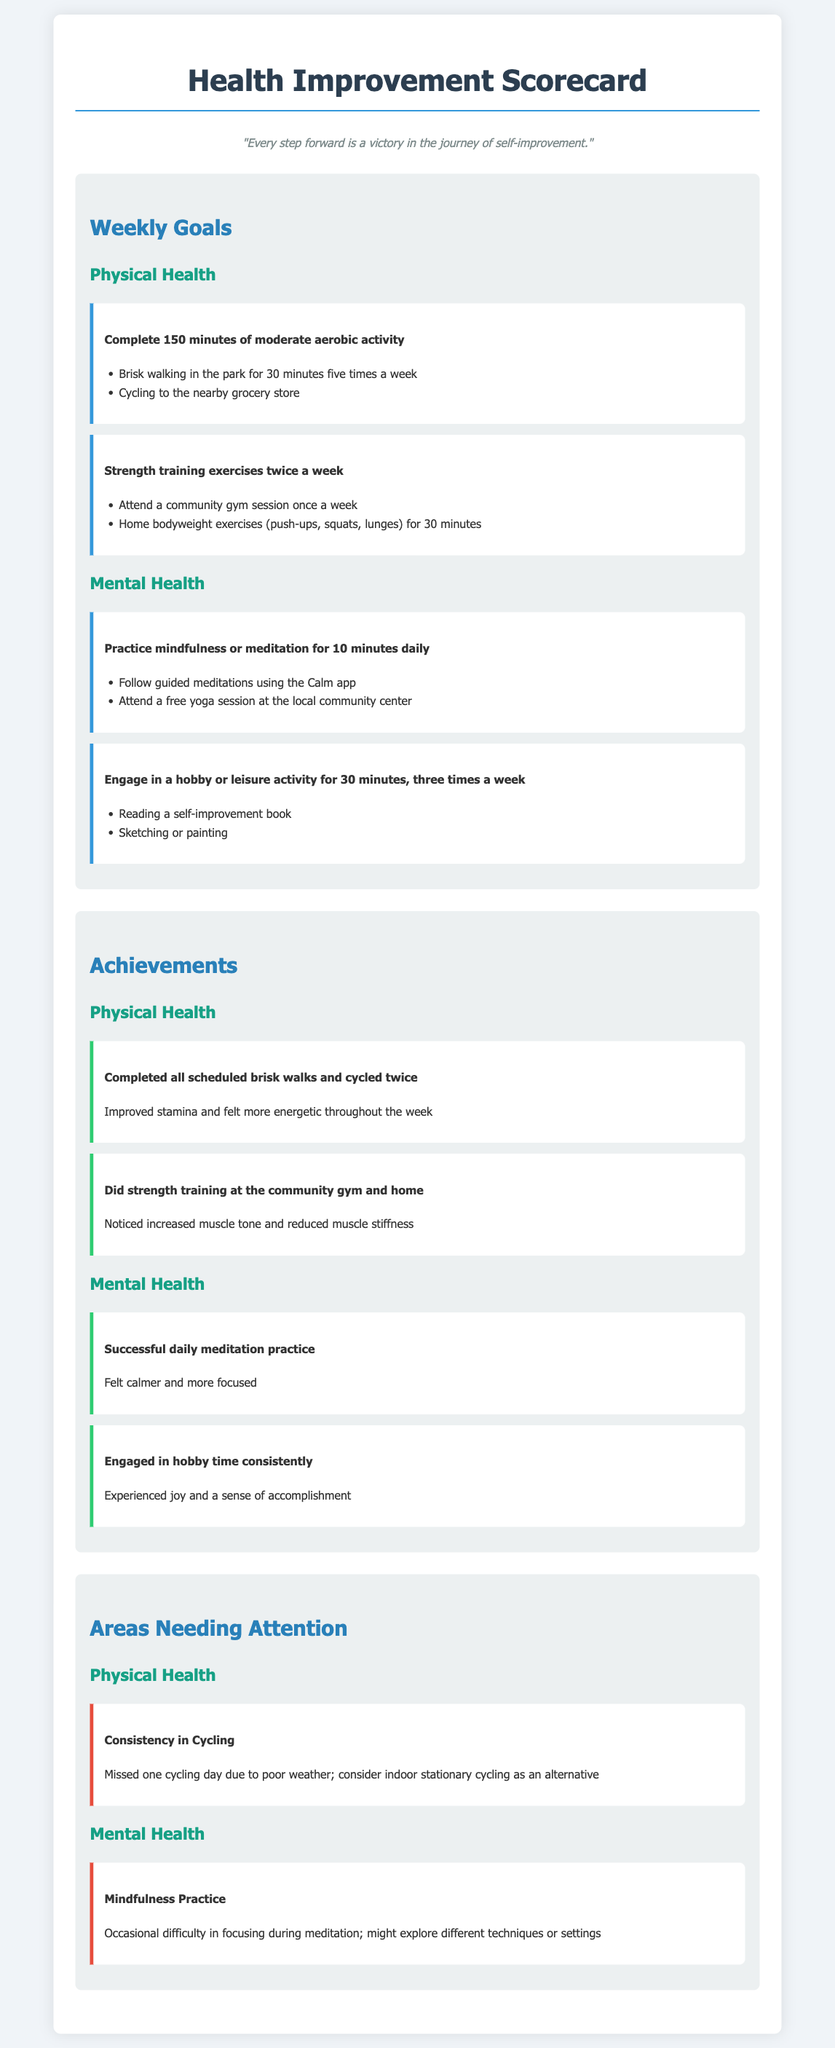What is the total amount of moderate aerobic activity to complete weekly? The total amount of moderate aerobic activity is specified as 150 minutes per week.
Answer: 150 minutes What is one physical health goal? One physical health goal is to complete 150 minutes of moderate aerobic activity.
Answer: Complete 150 minutes of moderate aerobic activity How many days a week should strength training be practiced? The document states strength training should be practiced twice a week.
Answer: Twice a week What was achieved regarding cycling? The achievement noted that the individual cycled twice during the week.
Answer: Cycled twice What area needs attention in mental health? The area needing attention in mental health is mindfulness practice.
Answer: Mindfulness practice How many hobby or leisure activities should be engaged in weekly? The document recommends engaging in a hobby or leisure activity for a minimum of three times a week.
Answer: Three times a week What is a benefit of the completed brisk walks? The benefit mentioned is improved stamina and feeling more energetic.
Answer: Improved stamina and felt more energetic What might be considered as an alternative for cycling on poor weather days? An alternative suggested for cycling on poor weather days is indoor stationary cycling.
Answer: Indoor stationary cycling What technique is recommended for improving focus during meditation? The document suggests exploring different techniques or settings for better focus during meditation.
Answer: Different techniques or settings 